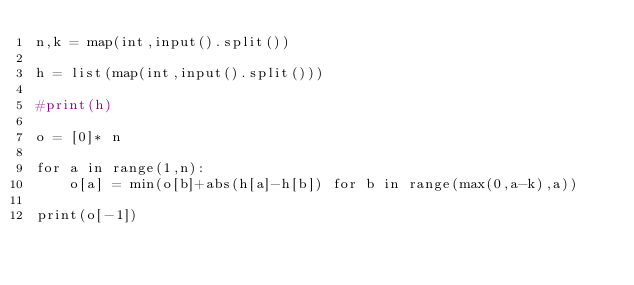Convert code to text. <code><loc_0><loc_0><loc_500><loc_500><_Python_>n,k = map(int,input().split())

h = list(map(int,input().split()))

#print(h)

o = [0]* n

for a in range(1,n):
    o[a] = min(o[b]+abs(h[a]-h[b]) for b in range(max(0,a-k),a))

print(o[-1])
</code> 